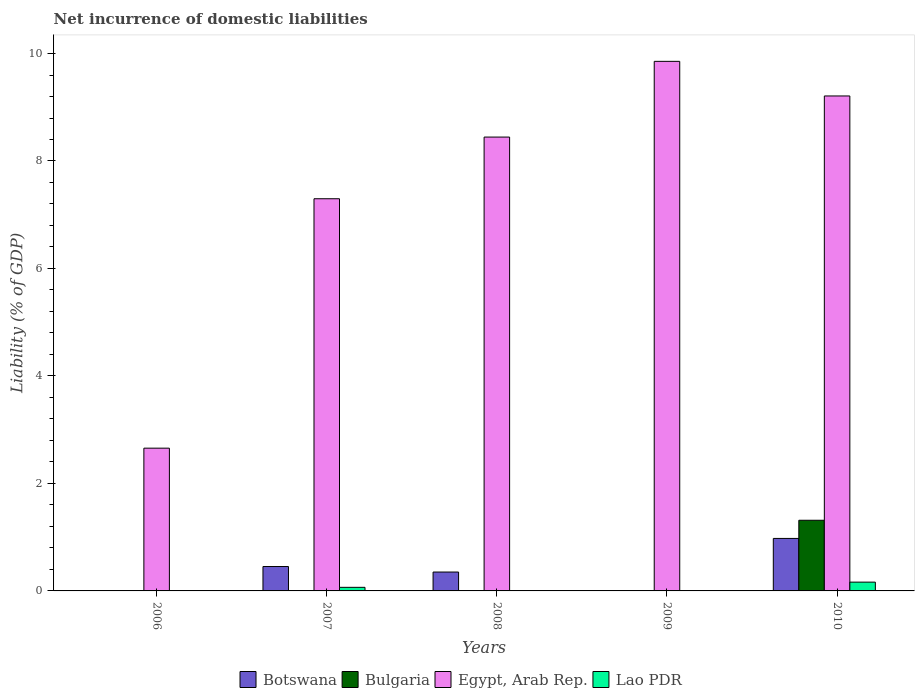How many different coloured bars are there?
Provide a short and direct response. 4. Are the number of bars on each tick of the X-axis equal?
Make the answer very short. No. What is the net incurrence of domestic liabilities in Lao PDR in 2009?
Your answer should be compact. 0. Across all years, what is the maximum net incurrence of domestic liabilities in Botswana?
Give a very brief answer. 0.98. Across all years, what is the minimum net incurrence of domestic liabilities in Bulgaria?
Your answer should be compact. 0. In which year was the net incurrence of domestic liabilities in Botswana maximum?
Your response must be concise. 2010. What is the total net incurrence of domestic liabilities in Botswana in the graph?
Provide a succinct answer. 1.78. What is the difference between the net incurrence of domestic liabilities in Botswana in 2007 and that in 2008?
Offer a very short reply. 0.1. What is the difference between the net incurrence of domestic liabilities in Egypt, Arab Rep. in 2008 and the net incurrence of domestic liabilities in Lao PDR in 2006?
Your answer should be very brief. 8.45. What is the average net incurrence of domestic liabilities in Bulgaria per year?
Offer a very short reply. 0.26. In the year 2008, what is the difference between the net incurrence of domestic liabilities in Botswana and net incurrence of domestic liabilities in Egypt, Arab Rep.?
Offer a terse response. -8.09. What is the ratio of the net incurrence of domestic liabilities in Egypt, Arab Rep. in 2008 to that in 2010?
Your answer should be compact. 0.92. Is the net incurrence of domestic liabilities in Egypt, Arab Rep. in 2007 less than that in 2009?
Provide a succinct answer. Yes. What is the difference between the highest and the second highest net incurrence of domestic liabilities in Egypt, Arab Rep.?
Your answer should be compact. 0.64. What is the difference between the highest and the lowest net incurrence of domestic liabilities in Botswana?
Provide a short and direct response. 0.98. Are all the bars in the graph horizontal?
Keep it short and to the point. No. Are the values on the major ticks of Y-axis written in scientific E-notation?
Your answer should be compact. No. Does the graph contain grids?
Give a very brief answer. No. How many legend labels are there?
Provide a short and direct response. 4. How are the legend labels stacked?
Keep it short and to the point. Horizontal. What is the title of the graph?
Offer a terse response. Net incurrence of domestic liabilities. What is the label or title of the Y-axis?
Provide a short and direct response. Liability (% of GDP). What is the Liability (% of GDP) in Bulgaria in 2006?
Ensure brevity in your answer.  0. What is the Liability (% of GDP) in Egypt, Arab Rep. in 2006?
Ensure brevity in your answer.  2.66. What is the Liability (% of GDP) of Lao PDR in 2006?
Your answer should be compact. 0. What is the Liability (% of GDP) in Botswana in 2007?
Make the answer very short. 0.45. What is the Liability (% of GDP) in Bulgaria in 2007?
Your answer should be very brief. 0. What is the Liability (% of GDP) in Egypt, Arab Rep. in 2007?
Your answer should be compact. 7.3. What is the Liability (% of GDP) in Lao PDR in 2007?
Your answer should be very brief. 0.07. What is the Liability (% of GDP) of Botswana in 2008?
Keep it short and to the point. 0.35. What is the Liability (% of GDP) in Egypt, Arab Rep. in 2008?
Your response must be concise. 8.45. What is the Liability (% of GDP) of Botswana in 2009?
Offer a terse response. 0. What is the Liability (% of GDP) in Egypt, Arab Rep. in 2009?
Provide a short and direct response. 9.85. What is the Liability (% of GDP) of Lao PDR in 2009?
Ensure brevity in your answer.  0. What is the Liability (% of GDP) of Botswana in 2010?
Offer a terse response. 0.98. What is the Liability (% of GDP) in Bulgaria in 2010?
Make the answer very short. 1.31. What is the Liability (% of GDP) in Egypt, Arab Rep. in 2010?
Your answer should be very brief. 9.21. What is the Liability (% of GDP) of Lao PDR in 2010?
Give a very brief answer. 0.16. Across all years, what is the maximum Liability (% of GDP) in Botswana?
Make the answer very short. 0.98. Across all years, what is the maximum Liability (% of GDP) in Bulgaria?
Ensure brevity in your answer.  1.31. Across all years, what is the maximum Liability (% of GDP) in Egypt, Arab Rep.?
Provide a succinct answer. 9.85. Across all years, what is the maximum Liability (% of GDP) in Lao PDR?
Give a very brief answer. 0.16. Across all years, what is the minimum Liability (% of GDP) of Botswana?
Your response must be concise. 0. Across all years, what is the minimum Liability (% of GDP) in Egypt, Arab Rep.?
Give a very brief answer. 2.66. Across all years, what is the minimum Liability (% of GDP) in Lao PDR?
Offer a very short reply. 0. What is the total Liability (% of GDP) of Botswana in the graph?
Make the answer very short. 1.78. What is the total Liability (% of GDP) of Bulgaria in the graph?
Your answer should be very brief. 1.31. What is the total Liability (% of GDP) of Egypt, Arab Rep. in the graph?
Offer a terse response. 37.46. What is the total Liability (% of GDP) in Lao PDR in the graph?
Keep it short and to the point. 0.23. What is the difference between the Liability (% of GDP) in Egypt, Arab Rep. in 2006 and that in 2007?
Keep it short and to the point. -4.64. What is the difference between the Liability (% of GDP) of Egypt, Arab Rep. in 2006 and that in 2008?
Your answer should be compact. -5.79. What is the difference between the Liability (% of GDP) in Egypt, Arab Rep. in 2006 and that in 2009?
Give a very brief answer. -7.2. What is the difference between the Liability (% of GDP) of Egypt, Arab Rep. in 2006 and that in 2010?
Keep it short and to the point. -6.55. What is the difference between the Liability (% of GDP) in Botswana in 2007 and that in 2008?
Your answer should be very brief. 0.1. What is the difference between the Liability (% of GDP) of Egypt, Arab Rep. in 2007 and that in 2008?
Ensure brevity in your answer.  -1.15. What is the difference between the Liability (% of GDP) in Egypt, Arab Rep. in 2007 and that in 2009?
Your answer should be compact. -2.56. What is the difference between the Liability (% of GDP) in Botswana in 2007 and that in 2010?
Offer a terse response. -0.52. What is the difference between the Liability (% of GDP) of Egypt, Arab Rep. in 2007 and that in 2010?
Your answer should be compact. -1.91. What is the difference between the Liability (% of GDP) in Lao PDR in 2007 and that in 2010?
Provide a short and direct response. -0.1. What is the difference between the Liability (% of GDP) in Egypt, Arab Rep. in 2008 and that in 2009?
Your answer should be very brief. -1.41. What is the difference between the Liability (% of GDP) in Botswana in 2008 and that in 2010?
Provide a succinct answer. -0.63. What is the difference between the Liability (% of GDP) in Egypt, Arab Rep. in 2008 and that in 2010?
Keep it short and to the point. -0.76. What is the difference between the Liability (% of GDP) in Egypt, Arab Rep. in 2009 and that in 2010?
Your response must be concise. 0.64. What is the difference between the Liability (% of GDP) of Egypt, Arab Rep. in 2006 and the Liability (% of GDP) of Lao PDR in 2007?
Give a very brief answer. 2.59. What is the difference between the Liability (% of GDP) in Egypt, Arab Rep. in 2006 and the Liability (% of GDP) in Lao PDR in 2010?
Keep it short and to the point. 2.49. What is the difference between the Liability (% of GDP) of Botswana in 2007 and the Liability (% of GDP) of Egypt, Arab Rep. in 2008?
Give a very brief answer. -7.99. What is the difference between the Liability (% of GDP) of Botswana in 2007 and the Liability (% of GDP) of Egypt, Arab Rep. in 2009?
Offer a very short reply. -9.4. What is the difference between the Liability (% of GDP) in Botswana in 2007 and the Liability (% of GDP) in Bulgaria in 2010?
Keep it short and to the point. -0.86. What is the difference between the Liability (% of GDP) in Botswana in 2007 and the Liability (% of GDP) in Egypt, Arab Rep. in 2010?
Give a very brief answer. -8.76. What is the difference between the Liability (% of GDP) in Botswana in 2007 and the Liability (% of GDP) in Lao PDR in 2010?
Keep it short and to the point. 0.29. What is the difference between the Liability (% of GDP) of Egypt, Arab Rep. in 2007 and the Liability (% of GDP) of Lao PDR in 2010?
Your response must be concise. 7.13. What is the difference between the Liability (% of GDP) in Botswana in 2008 and the Liability (% of GDP) in Egypt, Arab Rep. in 2009?
Offer a terse response. -9.5. What is the difference between the Liability (% of GDP) of Botswana in 2008 and the Liability (% of GDP) of Bulgaria in 2010?
Your response must be concise. -0.96. What is the difference between the Liability (% of GDP) in Botswana in 2008 and the Liability (% of GDP) in Egypt, Arab Rep. in 2010?
Your response must be concise. -8.86. What is the difference between the Liability (% of GDP) in Botswana in 2008 and the Liability (% of GDP) in Lao PDR in 2010?
Keep it short and to the point. 0.19. What is the difference between the Liability (% of GDP) in Egypt, Arab Rep. in 2008 and the Liability (% of GDP) in Lao PDR in 2010?
Your answer should be compact. 8.28. What is the difference between the Liability (% of GDP) of Egypt, Arab Rep. in 2009 and the Liability (% of GDP) of Lao PDR in 2010?
Offer a very short reply. 9.69. What is the average Liability (% of GDP) in Botswana per year?
Keep it short and to the point. 0.36. What is the average Liability (% of GDP) in Bulgaria per year?
Make the answer very short. 0.26. What is the average Liability (% of GDP) of Egypt, Arab Rep. per year?
Give a very brief answer. 7.49. What is the average Liability (% of GDP) in Lao PDR per year?
Your response must be concise. 0.05. In the year 2007, what is the difference between the Liability (% of GDP) in Botswana and Liability (% of GDP) in Egypt, Arab Rep.?
Provide a short and direct response. -6.84. In the year 2007, what is the difference between the Liability (% of GDP) in Botswana and Liability (% of GDP) in Lao PDR?
Your answer should be very brief. 0.39. In the year 2007, what is the difference between the Liability (% of GDP) of Egypt, Arab Rep. and Liability (% of GDP) of Lao PDR?
Give a very brief answer. 7.23. In the year 2008, what is the difference between the Liability (% of GDP) of Botswana and Liability (% of GDP) of Egypt, Arab Rep.?
Your answer should be compact. -8.09. In the year 2010, what is the difference between the Liability (% of GDP) of Botswana and Liability (% of GDP) of Bulgaria?
Give a very brief answer. -0.34. In the year 2010, what is the difference between the Liability (% of GDP) of Botswana and Liability (% of GDP) of Egypt, Arab Rep.?
Your answer should be compact. -8.23. In the year 2010, what is the difference between the Liability (% of GDP) of Botswana and Liability (% of GDP) of Lao PDR?
Give a very brief answer. 0.81. In the year 2010, what is the difference between the Liability (% of GDP) of Bulgaria and Liability (% of GDP) of Egypt, Arab Rep.?
Provide a succinct answer. -7.9. In the year 2010, what is the difference between the Liability (% of GDP) in Bulgaria and Liability (% of GDP) in Lao PDR?
Provide a short and direct response. 1.15. In the year 2010, what is the difference between the Liability (% of GDP) in Egypt, Arab Rep. and Liability (% of GDP) in Lao PDR?
Make the answer very short. 9.05. What is the ratio of the Liability (% of GDP) in Egypt, Arab Rep. in 2006 to that in 2007?
Offer a terse response. 0.36. What is the ratio of the Liability (% of GDP) in Egypt, Arab Rep. in 2006 to that in 2008?
Offer a terse response. 0.31. What is the ratio of the Liability (% of GDP) of Egypt, Arab Rep. in 2006 to that in 2009?
Your answer should be very brief. 0.27. What is the ratio of the Liability (% of GDP) in Egypt, Arab Rep. in 2006 to that in 2010?
Give a very brief answer. 0.29. What is the ratio of the Liability (% of GDP) of Botswana in 2007 to that in 2008?
Offer a very short reply. 1.29. What is the ratio of the Liability (% of GDP) in Egypt, Arab Rep. in 2007 to that in 2008?
Offer a terse response. 0.86. What is the ratio of the Liability (% of GDP) in Egypt, Arab Rep. in 2007 to that in 2009?
Give a very brief answer. 0.74. What is the ratio of the Liability (% of GDP) of Botswana in 2007 to that in 2010?
Your response must be concise. 0.46. What is the ratio of the Liability (% of GDP) of Egypt, Arab Rep. in 2007 to that in 2010?
Ensure brevity in your answer.  0.79. What is the ratio of the Liability (% of GDP) of Lao PDR in 2007 to that in 2010?
Your response must be concise. 0.41. What is the ratio of the Liability (% of GDP) of Egypt, Arab Rep. in 2008 to that in 2009?
Offer a terse response. 0.86. What is the ratio of the Liability (% of GDP) in Botswana in 2008 to that in 2010?
Keep it short and to the point. 0.36. What is the ratio of the Liability (% of GDP) in Egypt, Arab Rep. in 2008 to that in 2010?
Your answer should be very brief. 0.92. What is the ratio of the Liability (% of GDP) of Egypt, Arab Rep. in 2009 to that in 2010?
Your answer should be very brief. 1.07. What is the difference between the highest and the second highest Liability (% of GDP) in Botswana?
Keep it short and to the point. 0.52. What is the difference between the highest and the second highest Liability (% of GDP) in Egypt, Arab Rep.?
Your answer should be very brief. 0.64. What is the difference between the highest and the lowest Liability (% of GDP) in Botswana?
Ensure brevity in your answer.  0.98. What is the difference between the highest and the lowest Liability (% of GDP) in Bulgaria?
Your answer should be very brief. 1.31. What is the difference between the highest and the lowest Liability (% of GDP) of Egypt, Arab Rep.?
Provide a short and direct response. 7.2. What is the difference between the highest and the lowest Liability (% of GDP) of Lao PDR?
Provide a succinct answer. 0.16. 